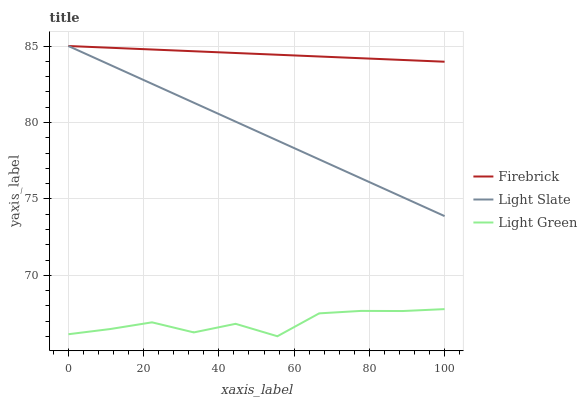Does Firebrick have the minimum area under the curve?
Answer yes or no. No. Does Light Green have the maximum area under the curve?
Answer yes or no. No. Is Light Green the smoothest?
Answer yes or no. No. Is Firebrick the roughest?
Answer yes or no. No. Does Firebrick have the lowest value?
Answer yes or no. No. Does Light Green have the highest value?
Answer yes or no. No. Is Light Green less than Light Slate?
Answer yes or no. Yes. Is Light Slate greater than Light Green?
Answer yes or no. Yes. Does Light Green intersect Light Slate?
Answer yes or no. No. 